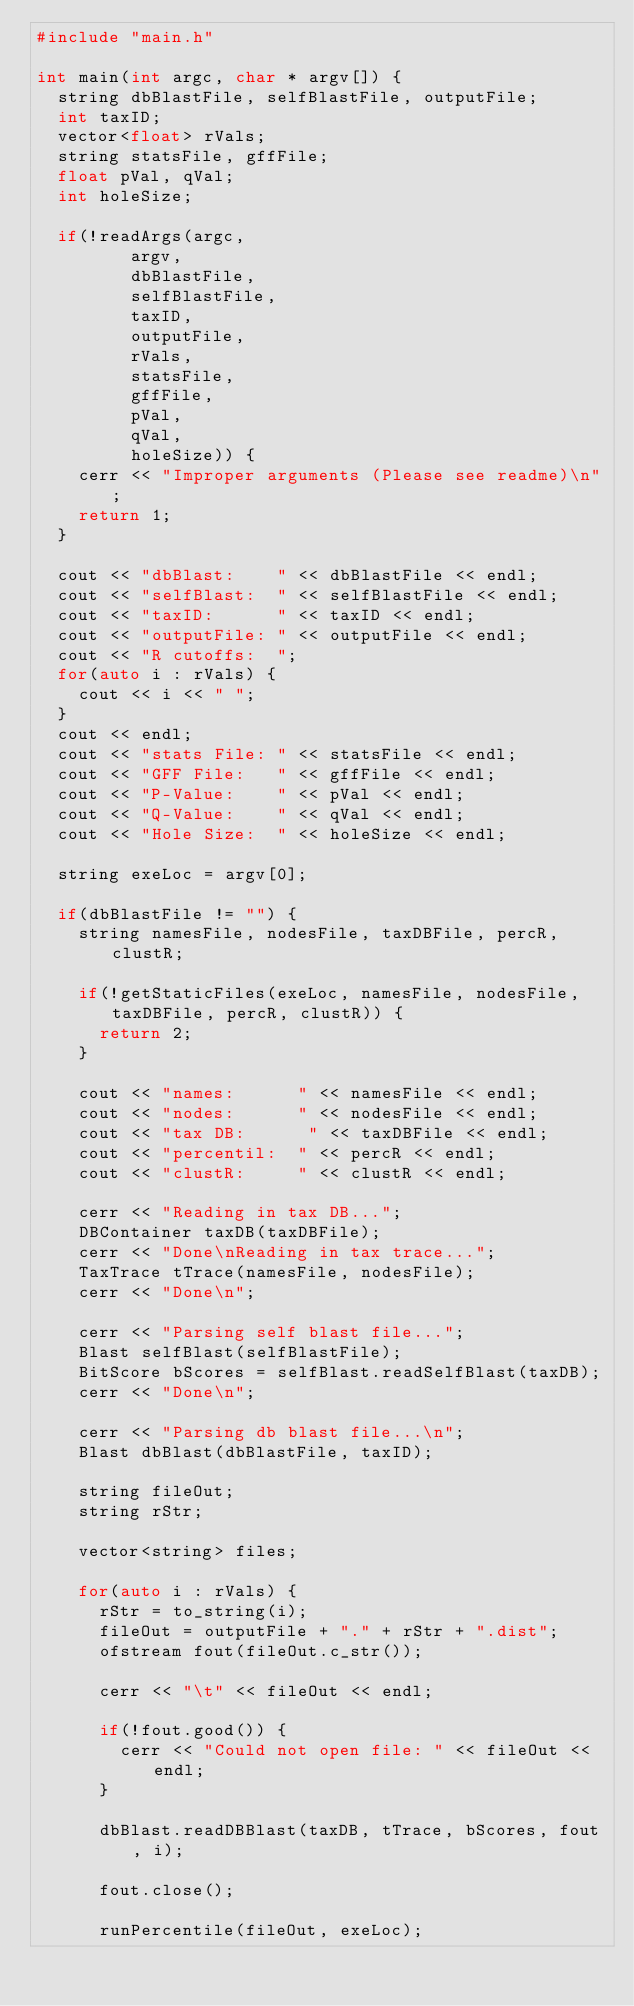Convert code to text. <code><loc_0><loc_0><loc_500><loc_500><_C++_>#include "main.h"

int main(int argc, char * argv[]) {
	string dbBlastFile, selfBlastFile, outputFile;
	int taxID;
	vector<float> rVals;
	string statsFile, gffFile;
	float pVal, qVal;
	int holeSize;

	if(!readArgs(argc, 
				 argv, 
				 dbBlastFile, 
				 selfBlastFile, 
				 taxID, 
				 outputFile, 
				 rVals,
				 statsFile,
				 gffFile,
				 pVal,
				 qVal,
				 holeSize)) {
		cerr << "Improper arguments (Please see readme)\n";
		return 1;
	}

	cout << "dbBlast:    " << dbBlastFile << endl;
	cout << "selfBlast:  " << selfBlastFile << endl;
	cout << "taxID:      " << taxID << endl;
	cout << "outputFile: " << outputFile << endl;
	cout << "R cutoffs:  ";
	for(auto i : rVals) {
		cout << i << " ";
	}
	cout << endl;
	cout << "stats File: " << statsFile << endl;
	cout << "GFF File:   " << gffFile << endl;
	cout << "P-Value:    " << pVal << endl;
	cout << "Q-Value:    " << qVal << endl;
	cout << "Hole Size:  " << holeSize << endl;

	string exeLoc = argv[0];

	if(dbBlastFile != "") {
		string namesFile, nodesFile, taxDBFile, percR, clustR;

		if(!getStaticFiles(exeLoc, namesFile, nodesFile, taxDBFile, percR, clustR)) {
			return 2;
		}

		cout << "names:      " << namesFile << endl;
		cout << "nodes:      " << nodesFile << endl;
		cout << "tax DB:      " << taxDBFile << endl;
		cout << "percentil:  " << percR << endl;
		cout << "clustR:     " << clustR << endl;

		cerr << "Reading in tax DB...";
		DBContainer taxDB(taxDBFile);
		cerr << "Done\nReading in tax trace...";
		TaxTrace tTrace(namesFile, nodesFile);
		cerr << "Done\n";

		cerr << "Parsing self blast file...";
		Blast selfBlast(selfBlastFile);
		BitScore bScores = selfBlast.readSelfBlast(taxDB);
		cerr << "Done\n";

		cerr << "Parsing db blast file...\n";
		Blast dbBlast(dbBlastFile, taxID);

		string fileOut;
		string rStr;

		vector<string> files;

		for(auto i : rVals) {
			rStr = to_string(i);
			fileOut = outputFile + "." + rStr + ".dist";
			ofstream fout(fileOut.c_str());

			cerr << "\t" << fileOut << endl;

			if(!fout.good()) {
				cerr << "Could not open file: " << fileOut << endl;
			}

			dbBlast.readDBBlast(taxDB, tTrace, bScores, fout, i);

			fout.close();

			runPercentile(fileOut, exeLoc);
</code> 